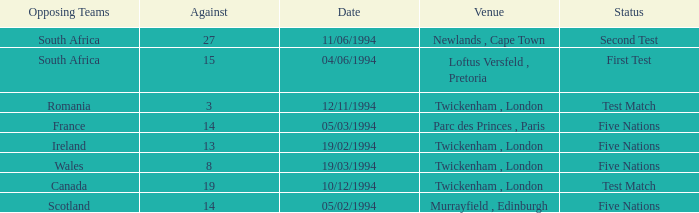How many against have a status of first test? 1.0. 